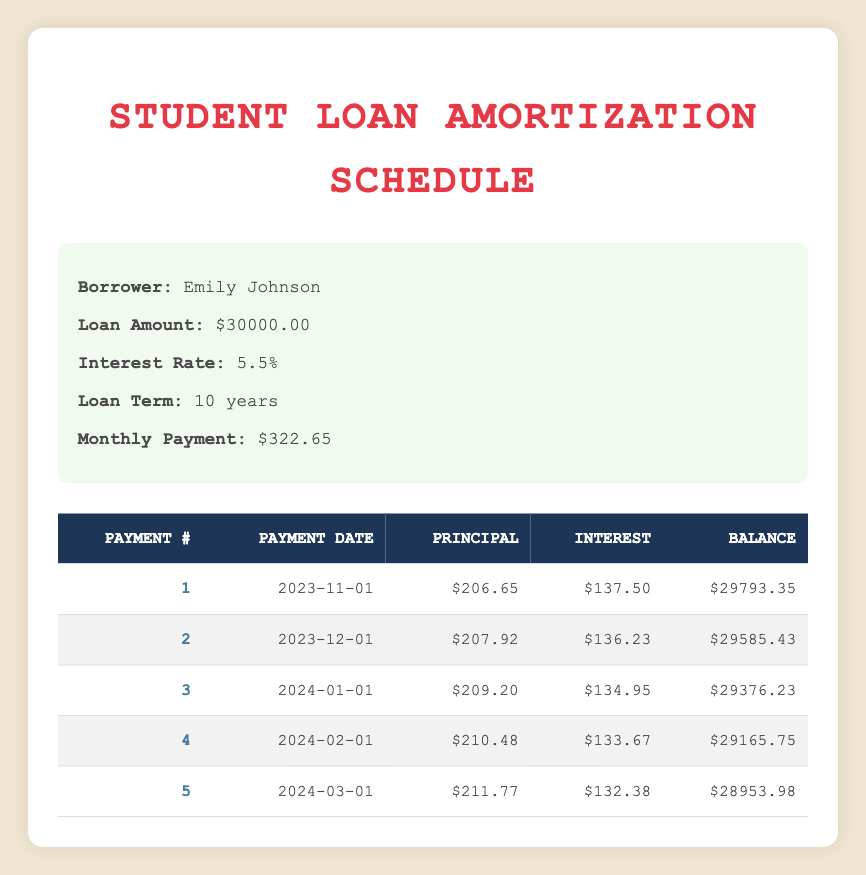What is the total loan amount taken by Emily Johnson? The loan amount is given in the loan details section of the table. It states that Emily Johnson took out a loan of 30000.
Answer: 30000 How much is the monthly payment? The monthly payment is also provided in the loan details section. It states that the monthly payment is 322.65.
Answer: 322.65 What is the interest payment for the first month? The table shows details for the first payment, including the interest payment. The first month's interest payment is 137.50.
Answer: 137.50 Which payment number has the highest principal payment? To find the payment number with the highest principal, look at the principal payments listed for each payment number. The highest principal payment is 211.77 in payment number 5.
Answer: 5 What is the remaining balance after the fifth payment? The remaining balance after the fifth payment is listed in the schedule. It shows a remaining balance of 28953.98 after the last payment (payment number 5).
Answer: 28953.98 Is the interest payment decreasing with each payment? To determine if the interest payment is decreasing, analyze the interest payments listed. They are: 137.50, 136.23, 134.95, 133.67, and 132.38, which shows a clear decrease.
Answer: Yes What is the total principal paid after the first five payments? Sum up the principal payments for the first five payments: 206.65 + 207.92 + 209.20 + 210.48 + 211.77 = 1065.02. Therefore, the total principal paid is 1065.02.
Answer: 1065.02 How much interest was paid in total over the first five payments? Sum the interest payments for the first five payments: 137.50 + 136.23 + 134.95 + 133.67 + 132.38 = 674.73. Thus, the total interest paid is 674.73.
Answer: 674.73 What is the average principal payment over the first five payments? To calculate the average principal payment, sum the principal payments: 206.65 + 207.92 + 209.20 + 210.48 + 211.77 = 1065.02. Since there are five payments, divide by 5: 1065.02 / 5 = 213.004. The average principal payment is 213.004.
Answer: 213.004 